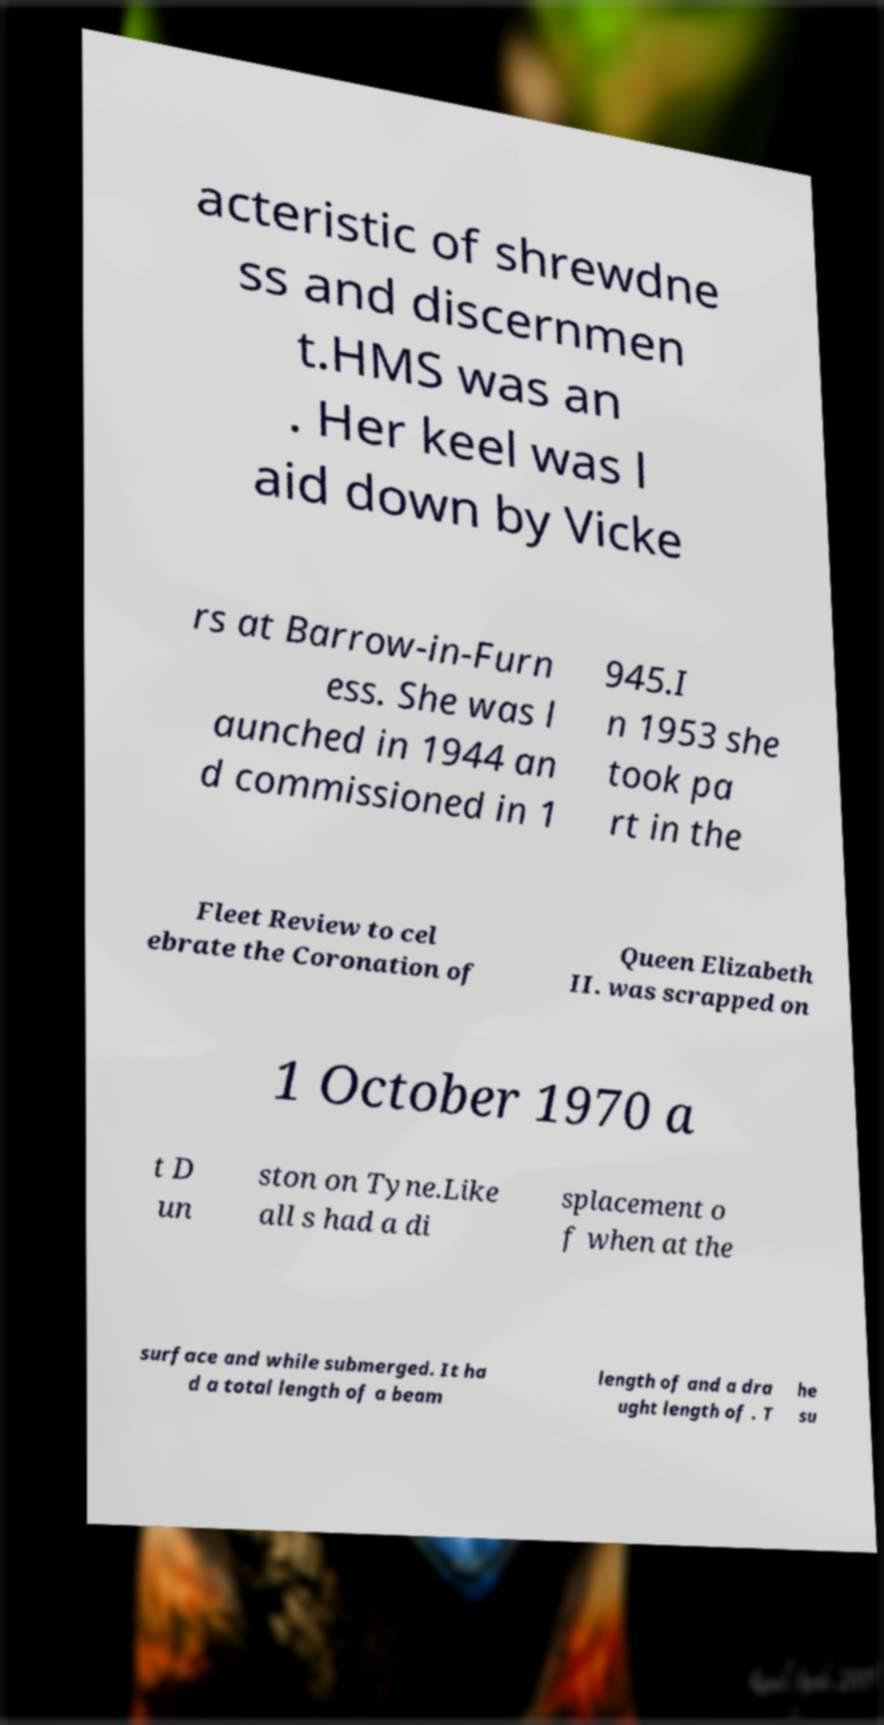Could you assist in decoding the text presented in this image and type it out clearly? acteristic of shrewdne ss and discernmen t.HMS was an . Her keel was l aid down by Vicke rs at Barrow-in-Furn ess. She was l aunched in 1944 an d commissioned in 1 945.I n 1953 she took pa rt in the Fleet Review to cel ebrate the Coronation of Queen Elizabeth II. was scrapped on 1 October 1970 a t D un ston on Tyne.Like all s had a di splacement o f when at the surface and while submerged. It ha d a total length of a beam length of and a dra ught length of . T he su 